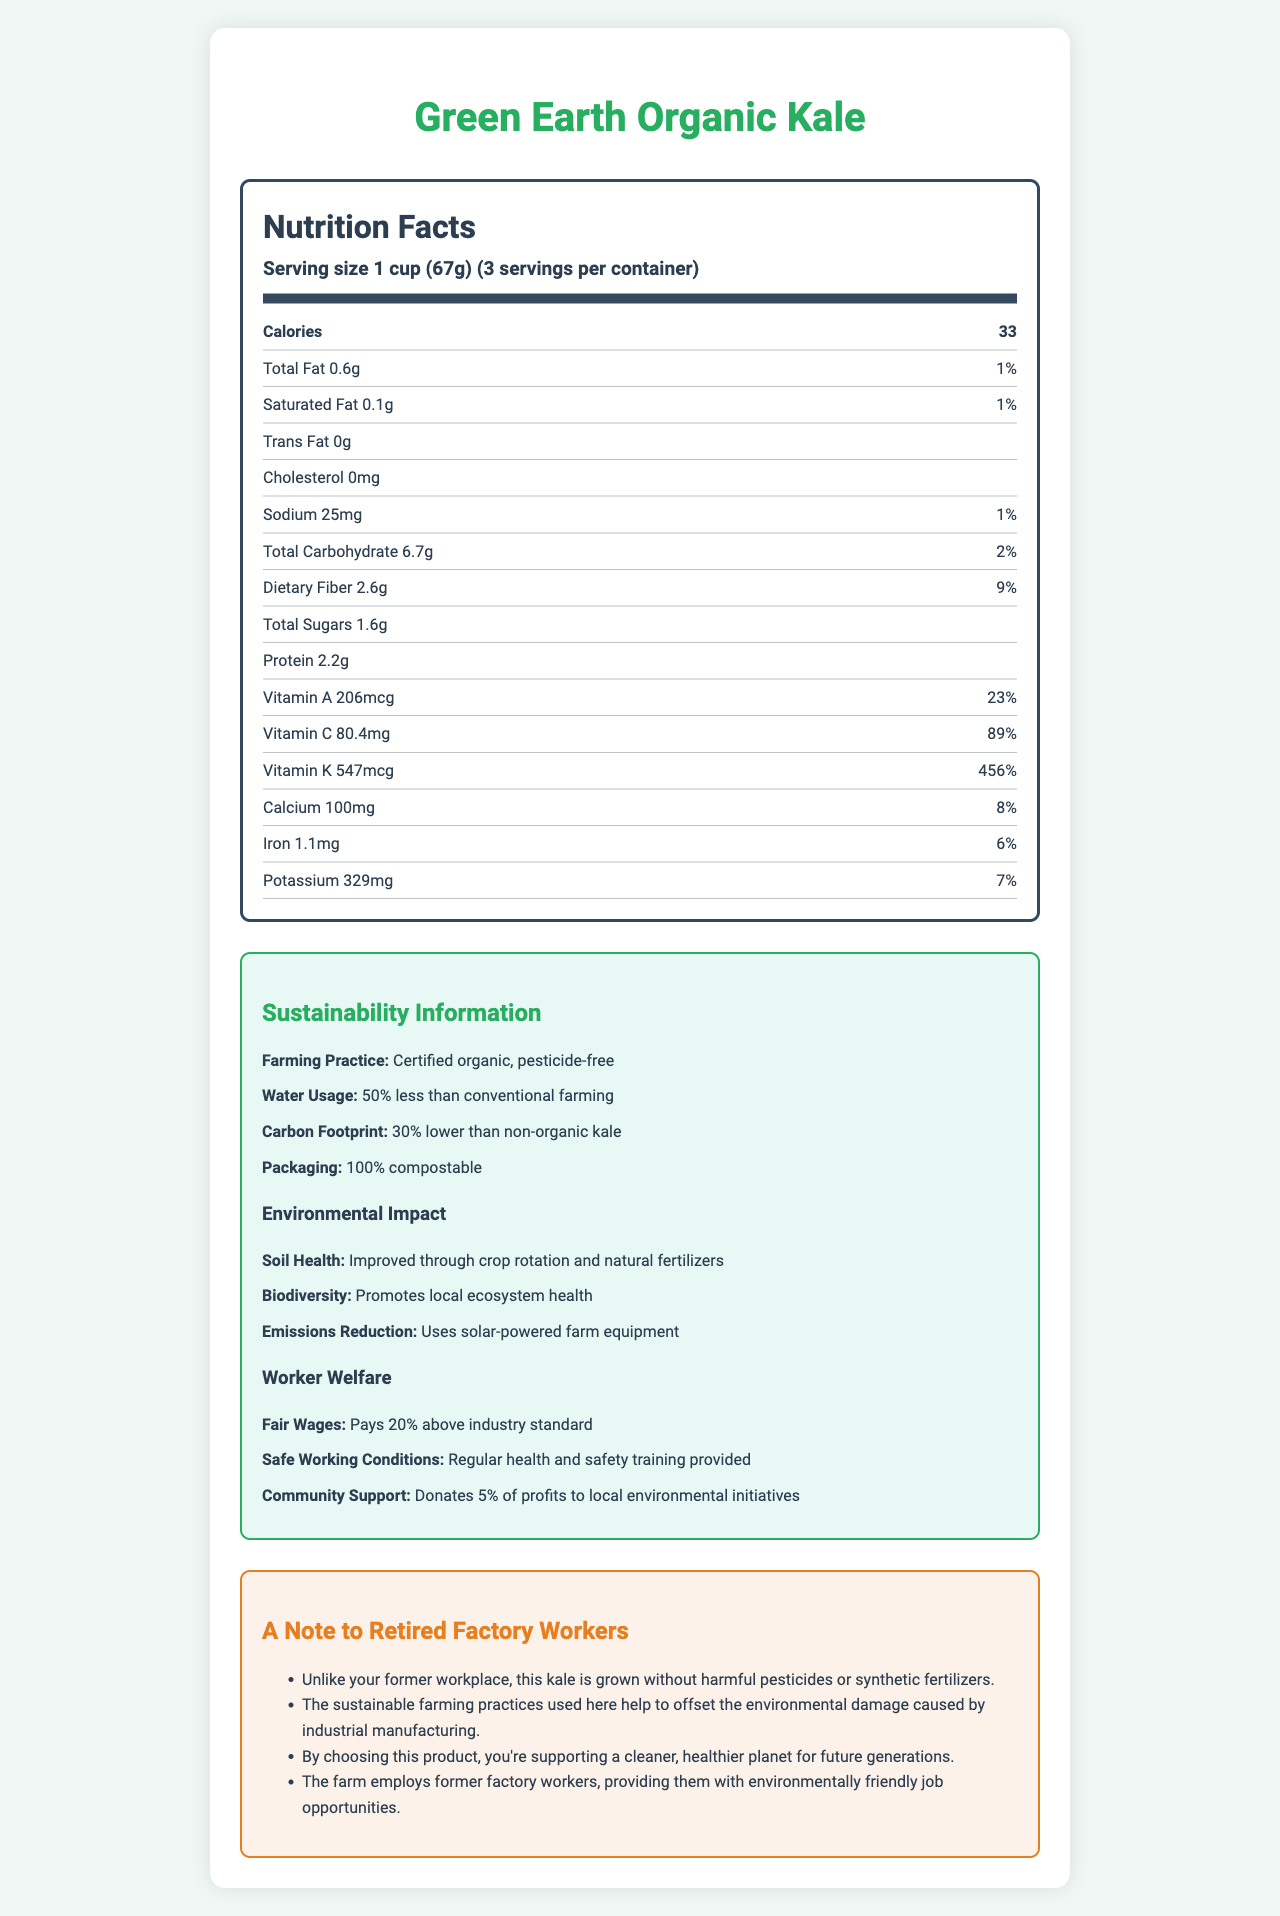what is the serving size? The serving size is stated at the beginning of the nutrition information as "Serving size 1 cup (67g)".
Answer: 1 cup (67g) how many calories are in one serving? The number of calories per serving is clearly listed as 33 in the nutrition facts.
Answer: 33 what percentage of the daily value is the vitamin C content? The daily value percentage for vitamin C is mentioned as 89% in the document.
Answer: 89% what is the total carbohydrate content in one serving? The total carbohydrate content is provided as 6.7g per serving.
Answer: 6.7g how much dietary fiber does one serving of the kale contain? The dietary fiber content is listed as 2.6g per serving.
Answer: 2.6g what is the farming practice used to grow this kale? A. Conventional B. Organic C. Hydroponic D. Synthetic The document states the farming practice as "Certified organic, pesticide-free".
Answer: B how much less water is used in the farming of this kale compared to conventional farming? 1. 10% 2. 25% 3. 50% 4. 75% The document states that the water usage is "50% less than conventional farming".
Answer: 3 is this product cholesterol-free? The document lists the cholesterol content as "0mg", indicating it is cholesterol-free.
Answer: Yes summarize the nutrition and environmental benefits of "Green Earth Organic Kale". This summary captures both the nutritional information and the environmental and worker welfare benefits presented in the document.
Answer: The "Green Earth Organic Kale" provides significant nutritional benefits, including being a low-calorie food rich in vitamins A, C, and K. The kale is grown using sustainable farming practices that reduce water usage and carbon footprint. The farming methods improve soil health and biodiversity, and the packaging is compostable. Worker welfare is also a priority, with fair wages and community support initiatives. what is the iron content in one serving? The iron content per serving is listed as 1.1mg in the document.
Answer: 1.1mg how does this kale impact soil health? The environmental impact section states that soil health is improved through crop rotation and natural fertilizers.
Answer: Improved through crop rotation and natural fertilizers how does this product support former factory workers like yourself? One of the persona-specific notes mentions that the farm employs former factory workers, offering them environmentally friendly jobs.
Answer: The farm employs former factory workers, providing them with environmentally friendly job opportunities. what is the amount of potassium in one serving? The potassium content per serving is listed as 329mg in the document.
Answer: 329mg what are the conditions that ensure worker welfare on this farm? These conditions are detailed in the worker welfare section of the document.
Answer: Pay 20% above industry standard, safe working conditions with regular health and safety training, community support through donations to local environmental initiatives. what is the percentage of the daily value for calcium in one serving? The daily percentage value for calcium is listed as 8% in the document.
Answer: 8% how do sustainable farming practices help the environment according to the document? The document lists several benefits of sustainable farming practices, including reduced carbon footprint, improved soil health and local ecosystem health, and the use of solar-powered equipment.
Answer: Reduces carbon footprint, improves soil health, promotes local ecosystem health, uses solar-powered farm equipment. can this document explain the exact chemical composition of the kale? The document does not provide detailed chemical composition information; it primarily offers nutritional values and sustainability information.
Answer: Cannot be determined 